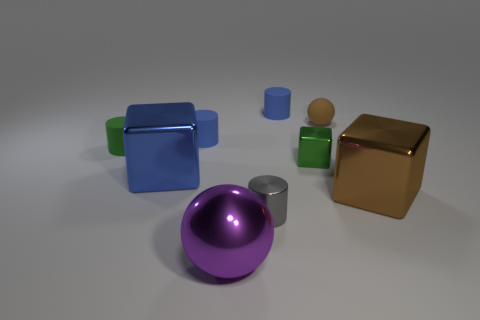How many blue things are either rubber cylinders or metallic spheres?
Ensure brevity in your answer.  2. Is the number of tiny green matte objects to the left of the tiny green cylinder less than the number of large metal blocks?
Keep it short and to the point. Yes. How many large brown shiny cubes are to the right of the large cube right of the gray metallic cylinder?
Your answer should be very brief. 0. What number of other objects are there of the same size as the brown ball?
Your response must be concise. 5. How many things are either blue matte things or big metal things that are left of the shiny ball?
Provide a short and direct response. 3. Are there fewer matte blocks than small brown objects?
Your answer should be compact. Yes. What color is the tiny cylinder in front of the large block to the right of the big sphere?
Your response must be concise. Gray. What is the material of the gray object that is the same shape as the tiny green rubber object?
Provide a succinct answer. Metal. How many metal things are cylinders or tiny blue cylinders?
Offer a terse response. 1. Do the large brown cube on the right side of the gray metal object and the cylinder that is behind the brown ball have the same material?
Offer a terse response. No. 